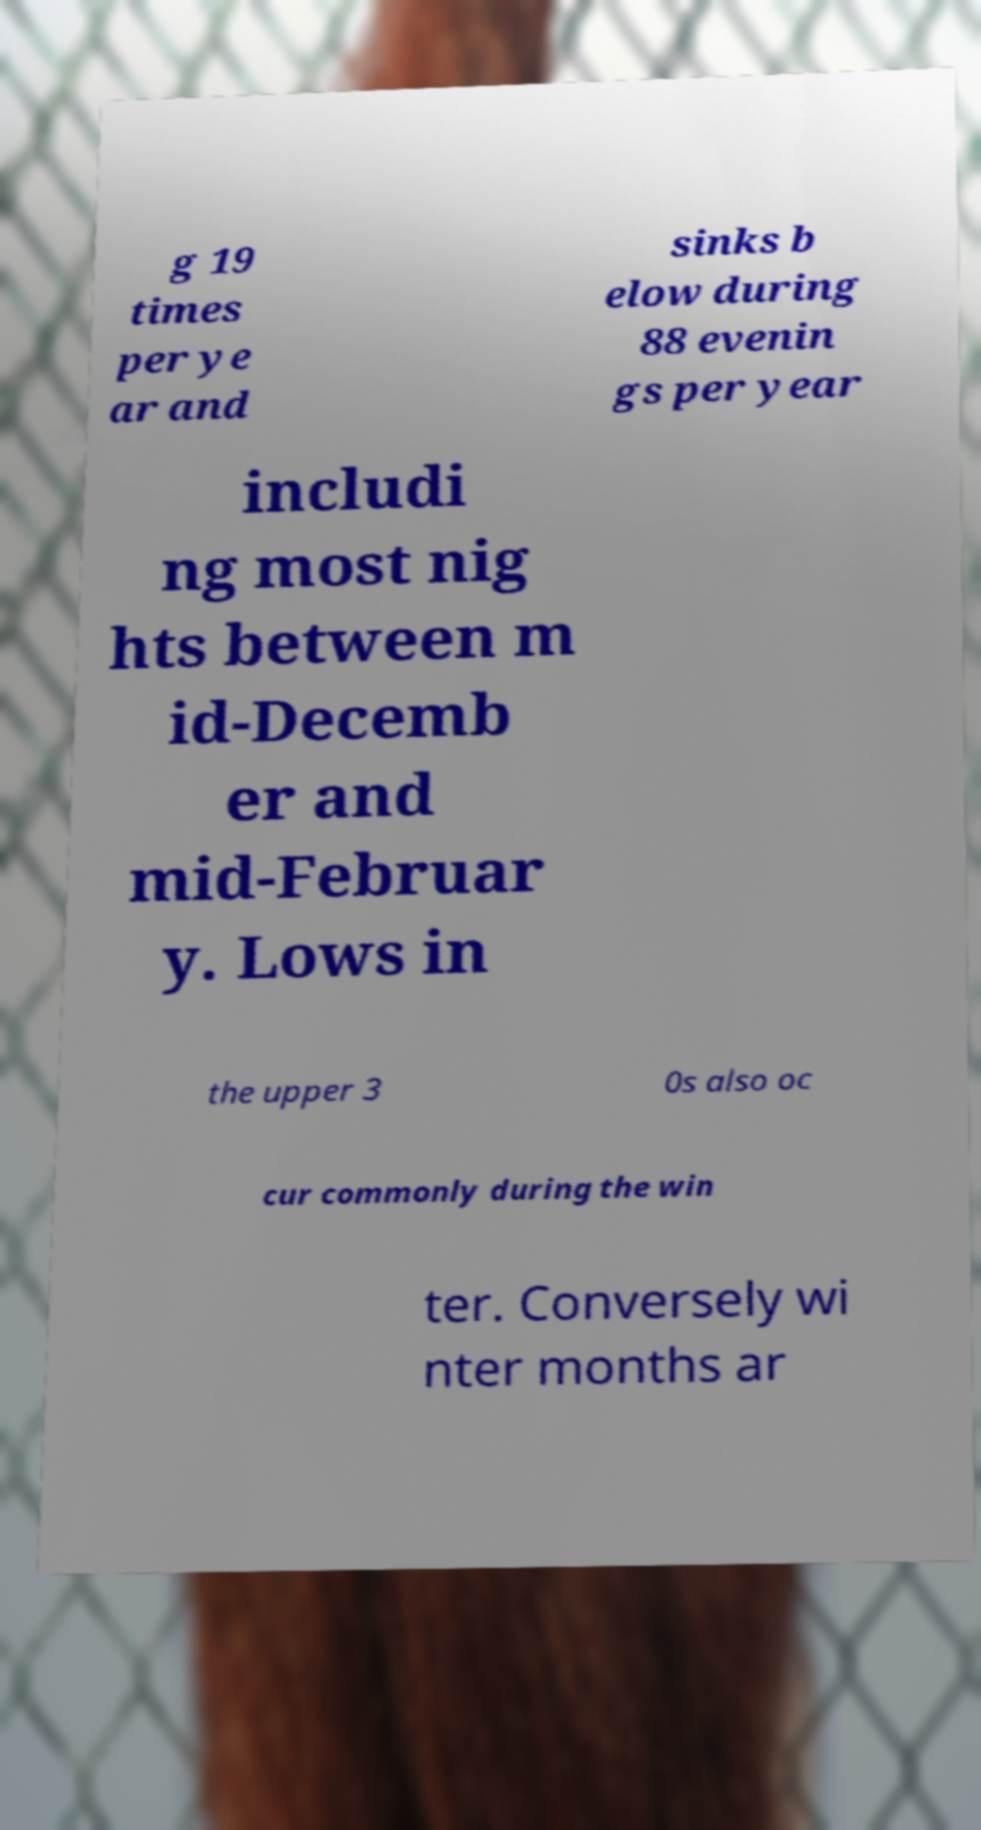Can you read and provide the text displayed in the image?This photo seems to have some interesting text. Can you extract and type it out for me? g 19 times per ye ar and sinks b elow during 88 evenin gs per year includi ng most nig hts between m id-Decemb er and mid-Februar y. Lows in the upper 3 0s also oc cur commonly during the win ter. Conversely wi nter months ar 